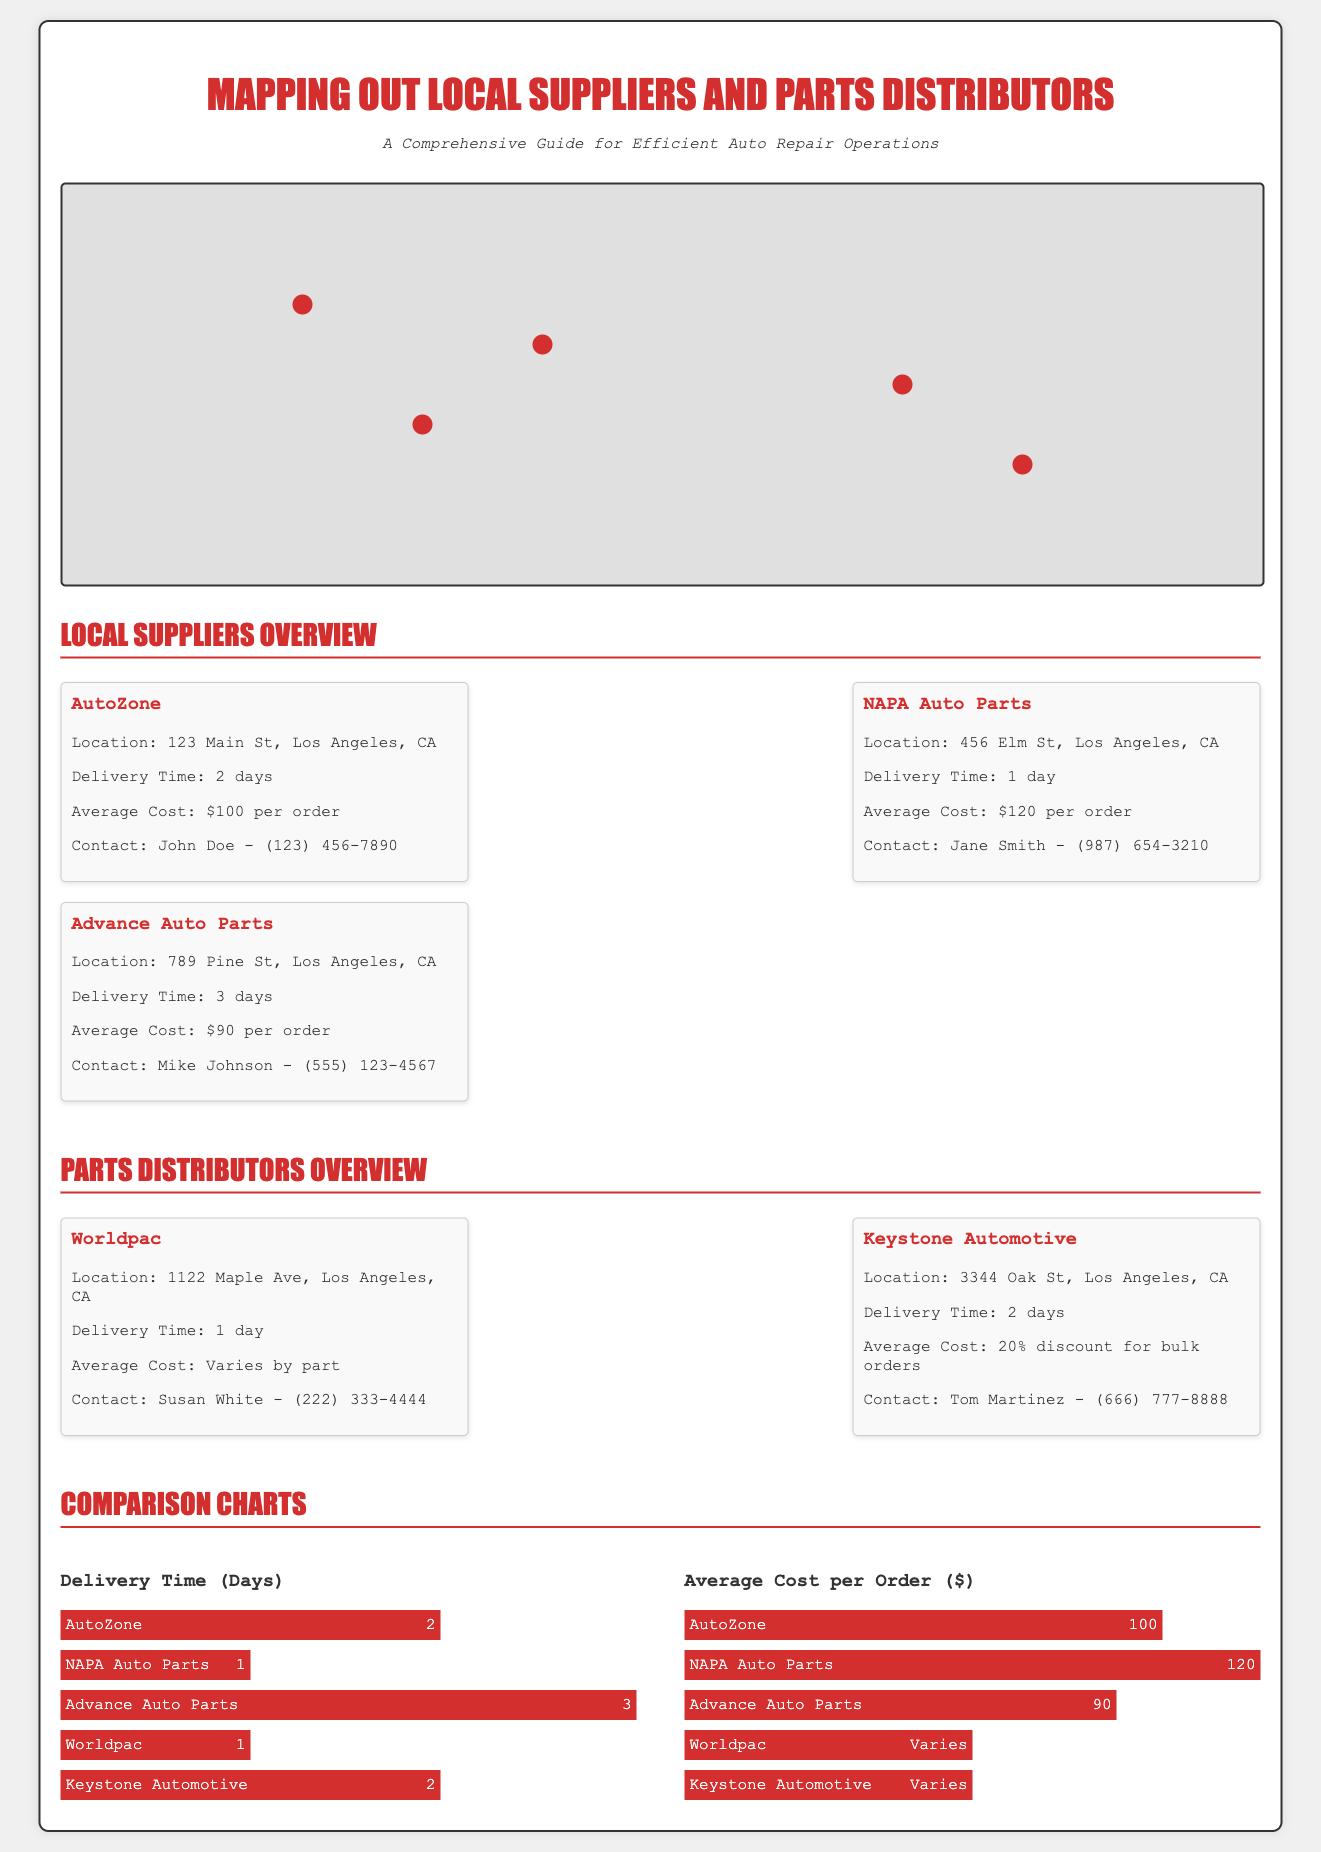What is the location of AutoZone? AutoZone is located at 123 Main St, Los Angeles, CA as stated in the document.
Answer: 123 Main St, Los Angeles, CA What is the average cost per order for Advance Auto Parts? The average cost per order for Advance Auto Parts is mentioned as $90 per order.
Answer: $90 Which supplier has the fastest delivery time? The fastest delivery time in the document is listed as 1 day, provided by NAPA Auto Parts and Worldpac.
Answer: NAPA Auto Parts What is the delivery time for Keystone Automotive? The document states that Keystone Automotive has a delivery time of 2 days.
Answer: 2 days How many suppliers are listed in the document? The document contains a total of 5 suppliers and parts distributors.
Answer: 5 Which supplier offers a discount for bulk orders? The document indicates that Keystone Automotive offers a 20% discount for bulk orders.
Answer: Keystone Automotive What company has the highest average cost per order? The highest average cost per order listed is from NAPA Auto Parts at $120.
Answer: NAPA Auto Parts What is the contact name for Advance Auto Parts? The contact name for Advance Auto Parts is Mike Johnson according to the document.
Answer: Mike Johnson What is the primary purpose of this infographic? The infographic is designed to provide a comprehensive guide for efficient auto repair operations through mapping suppliers.
Answer: To provide a comprehensive guide for efficient auto repair operations 